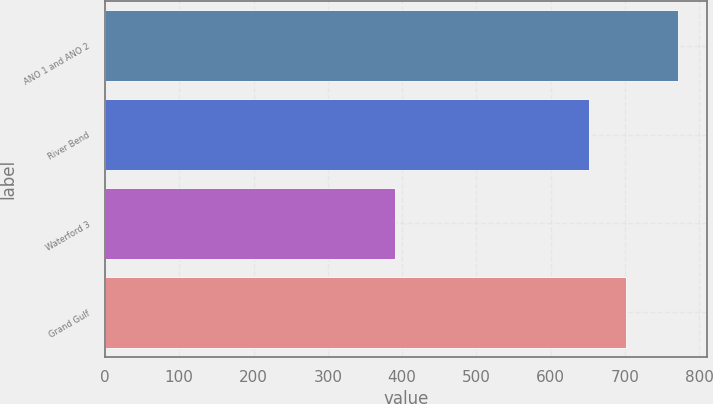<chart> <loc_0><loc_0><loc_500><loc_500><bar_chart><fcel>ANO 1 and ANO 2<fcel>River Bend<fcel>Waterford 3<fcel>Grand Gulf<nl><fcel>771.3<fcel>651.7<fcel>390.6<fcel>701.5<nl></chart> 